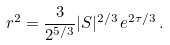Convert formula to latex. <formula><loc_0><loc_0><loc_500><loc_500>r ^ { 2 } = \frac { 3 } { 2 ^ { 5 / 3 } } | S | ^ { 2 / 3 } \, e ^ { 2 \tau / 3 } \, .</formula> 